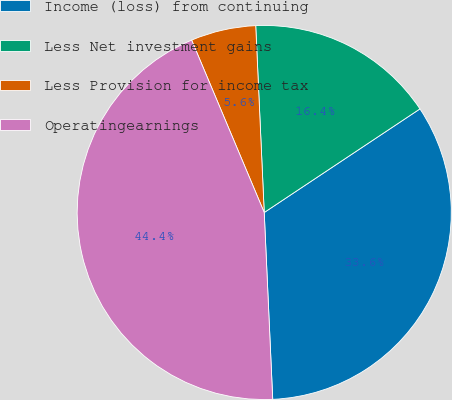<chart> <loc_0><loc_0><loc_500><loc_500><pie_chart><fcel>Income (loss) from continuing<fcel>Less Net investment gains<fcel>Less Provision for income tax<fcel>Operatingearnings<nl><fcel>33.62%<fcel>16.38%<fcel>5.62%<fcel>44.38%<nl></chart> 